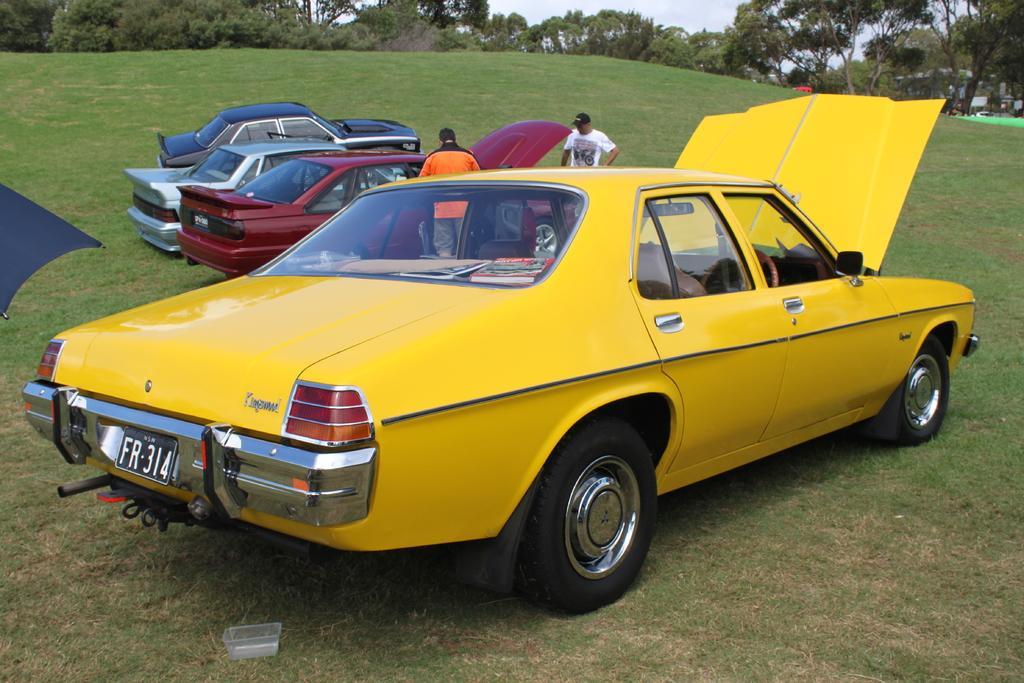Could you give a brief overview of what you see in this image? As we can see in the image there are two people, cars, grass and trees. On the top there is sky. 